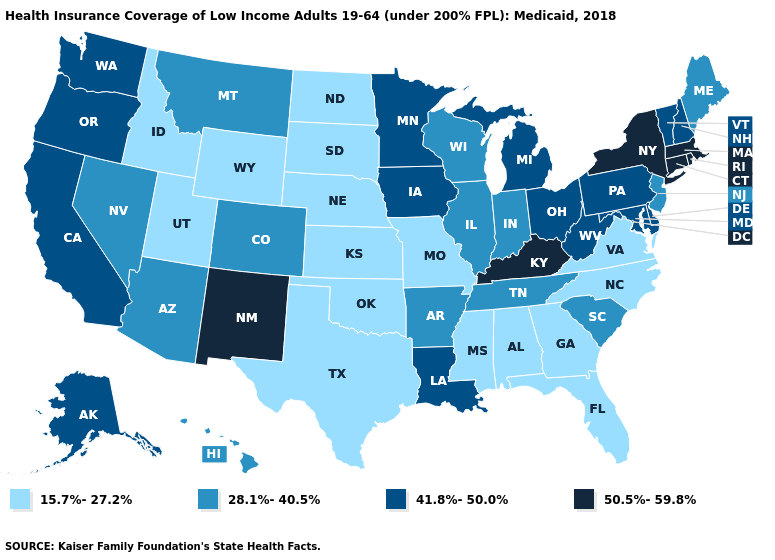Among the states that border Iowa , which have the lowest value?
Write a very short answer. Missouri, Nebraska, South Dakota. How many symbols are there in the legend?
Concise answer only. 4. Is the legend a continuous bar?
Short answer required. No. What is the value of Illinois?
Give a very brief answer. 28.1%-40.5%. Does Maine have the same value as Alabama?
Keep it brief. No. What is the highest value in the USA?
Short answer required. 50.5%-59.8%. Does the map have missing data?
Short answer required. No. Which states have the lowest value in the USA?
Write a very short answer. Alabama, Florida, Georgia, Idaho, Kansas, Mississippi, Missouri, Nebraska, North Carolina, North Dakota, Oklahoma, South Dakota, Texas, Utah, Virginia, Wyoming. What is the value of Indiana?
Quick response, please. 28.1%-40.5%. What is the value of Nebraska?
Short answer required. 15.7%-27.2%. What is the value of Maine?
Be succinct. 28.1%-40.5%. What is the lowest value in the USA?
Give a very brief answer. 15.7%-27.2%. Does Nevada have the lowest value in the USA?
Give a very brief answer. No. Does the first symbol in the legend represent the smallest category?
Short answer required. Yes. Name the states that have a value in the range 28.1%-40.5%?
Write a very short answer. Arizona, Arkansas, Colorado, Hawaii, Illinois, Indiana, Maine, Montana, Nevada, New Jersey, South Carolina, Tennessee, Wisconsin. 